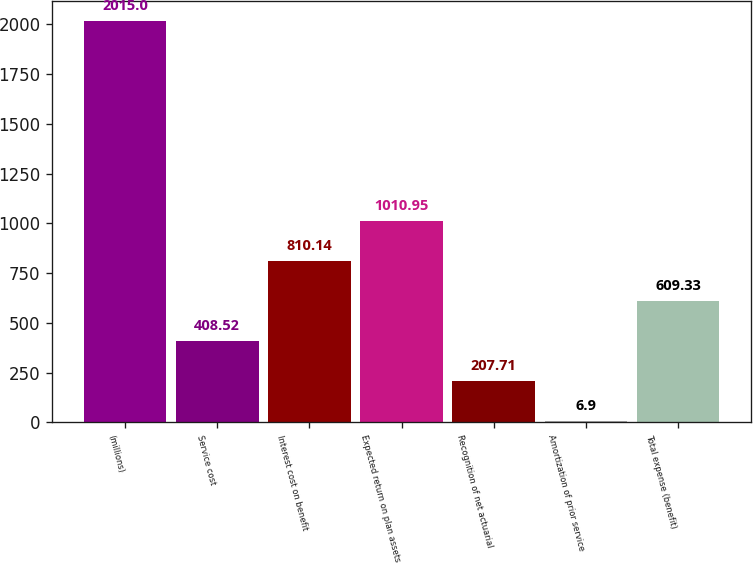Convert chart to OTSL. <chart><loc_0><loc_0><loc_500><loc_500><bar_chart><fcel>(millions)<fcel>Service cost<fcel>Interest cost on benefit<fcel>Expected return on plan assets<fcel>Recognition of net actuarial<fcel>Amortization of prior service<fcel>Total expense (benefit)<nl><fcel>2015<fcel>408.52<fcel>810.14<fcel>1010.95<fcel>207.71<fcel>6.9<fcel>609.33<nl></chart> 